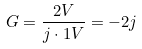<formula> <loc_0><loc_0><loc_500><loc_500>G = \frac { 2 V } { j \cdot 1 V } = - 2 j</formula> 